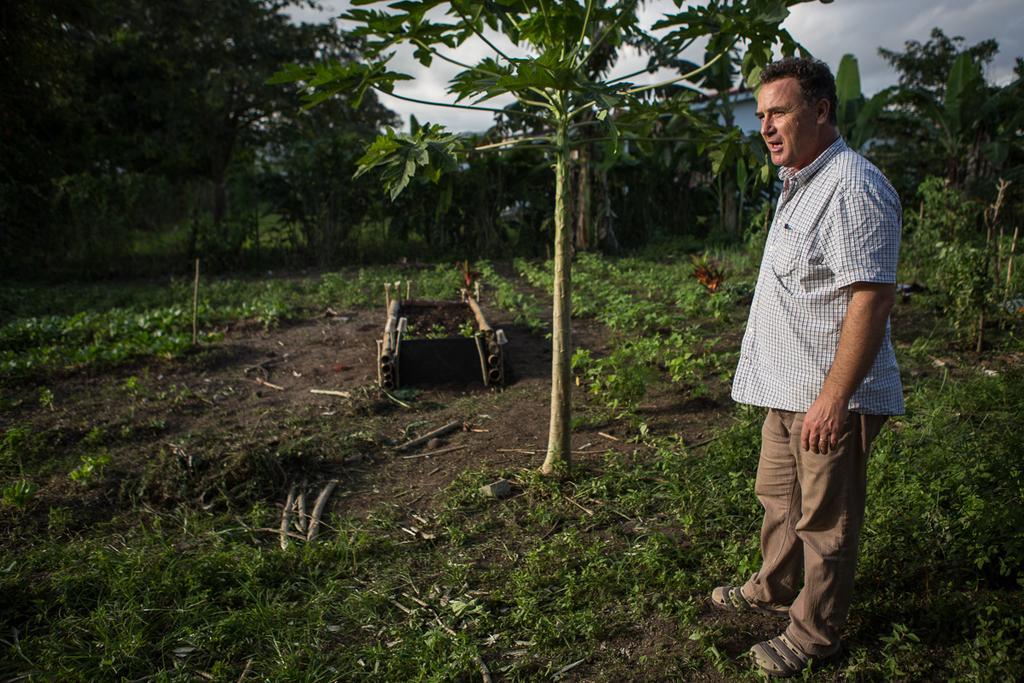Please provide a concise description of this image. A man is standing at the right wearing a shirt and trousers. There is grass and trees. 